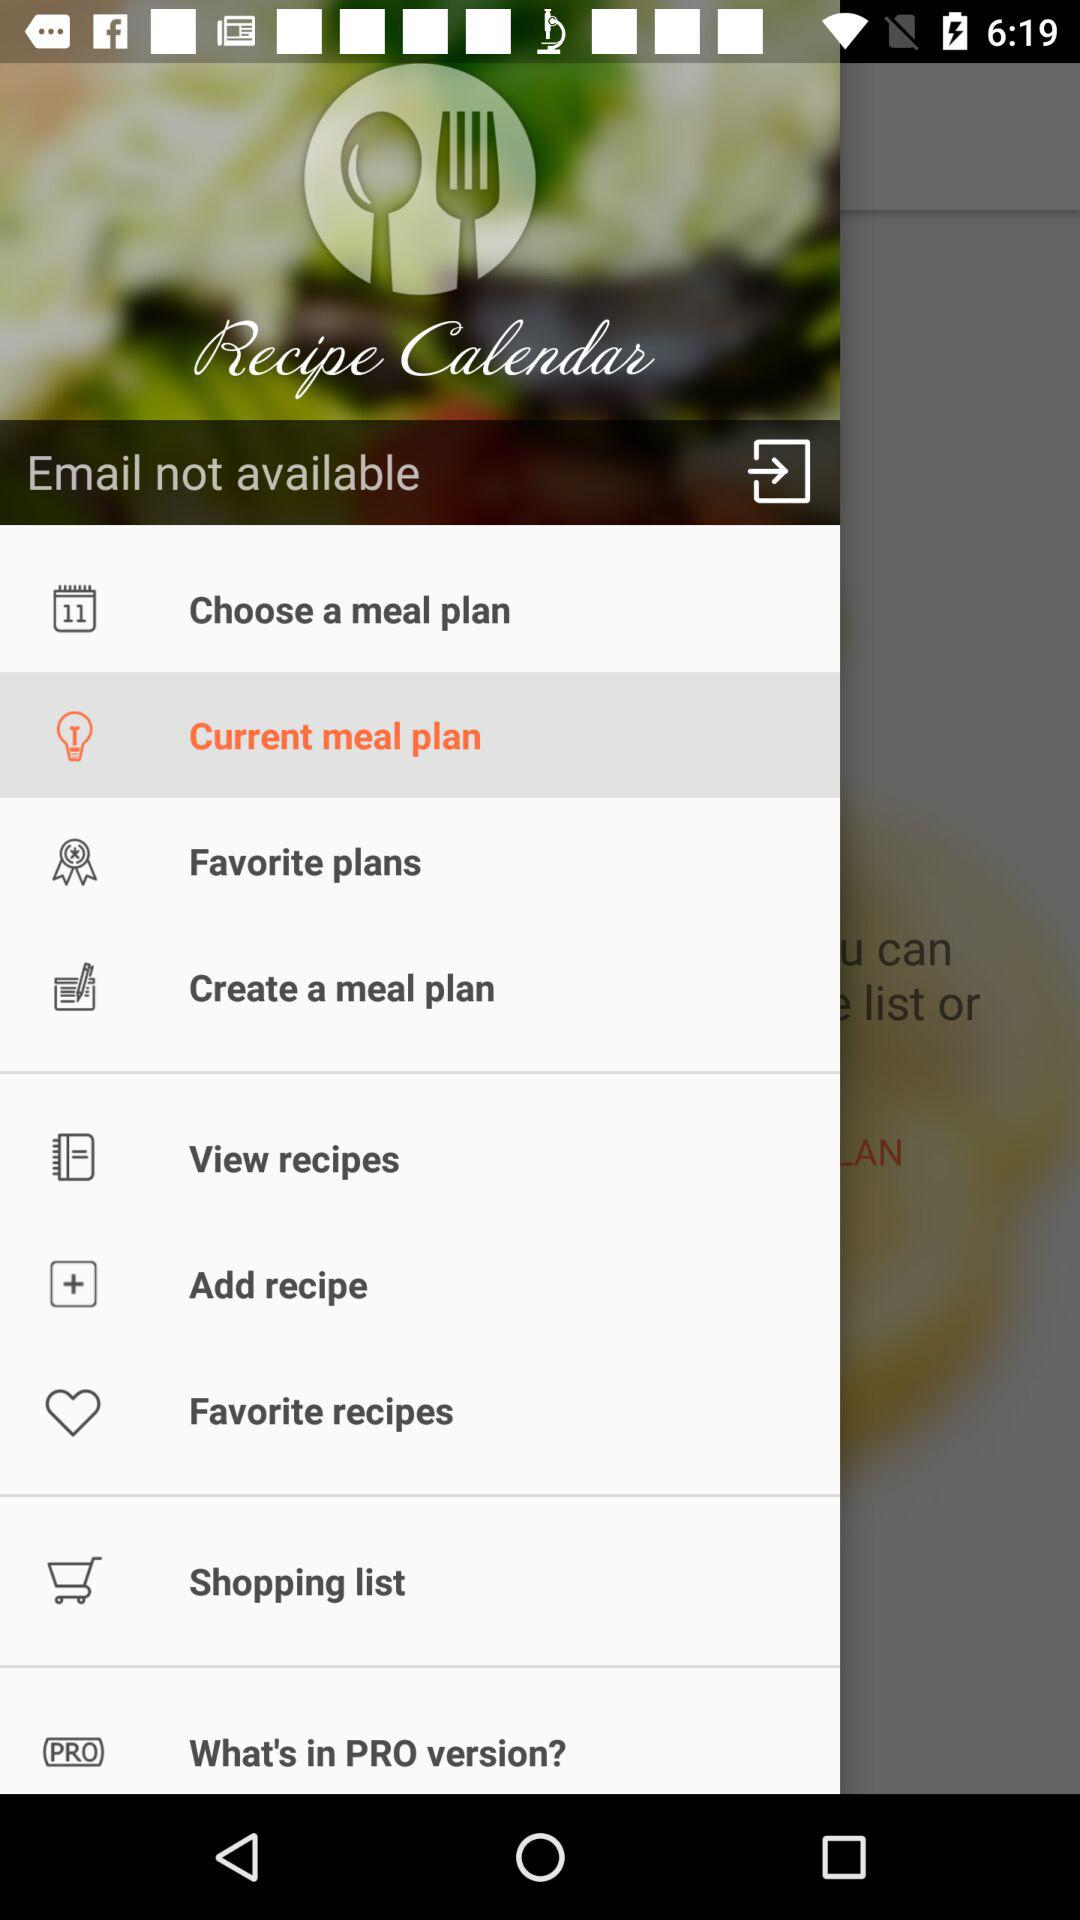What is the name of the application? The name of the application is "Recipe Calendar". 